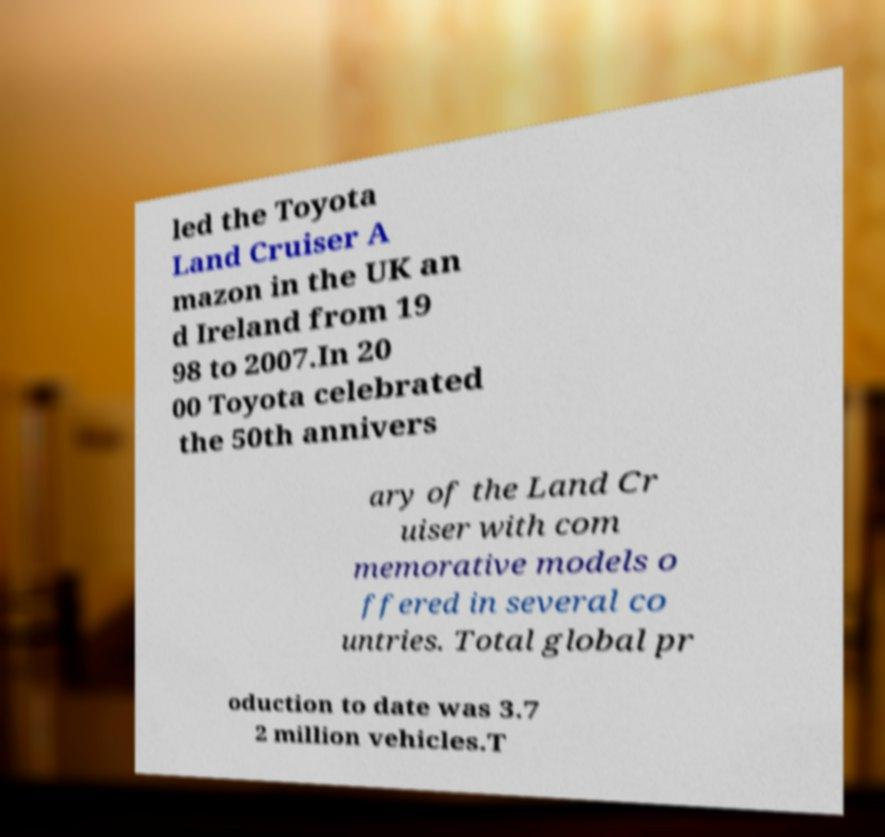Please identify and transcribe the text found in this image. led the Toyota Land Cruiser A mazon in the UK an d Ireland from 19 98 to 2007.In 20 00 Toyota celebrated the 50th annivers ary of the Land Cr uiser with com memorative models o ffered in several co untries. Total global pr oduction to date was 3.7 2 million vehicles.T 